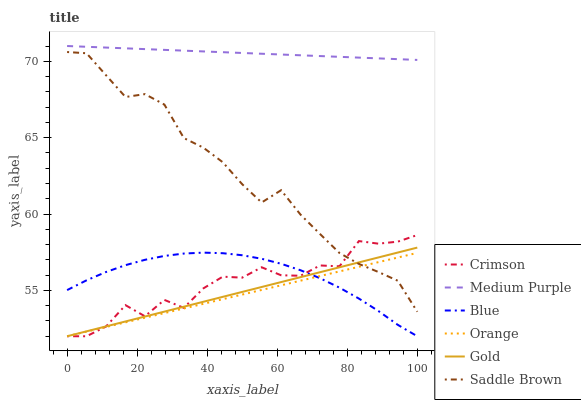Does Orange have the minimum area under the curve?
Answer yes or no. Yes. Does Medium Purple have the maximum area under the curve?
Answer yes or no. Yes. Does Gold have the minimum area under the curve?
Answer yes or no. No. Does Gold have the maximum area under the curve?
Answer yes or no. No. Is Medium Purple the smoothest?
Answer yes or no. Yes. Is Crimson the roughest?
Answer yes or no. Yes. Is Gold the smoothest?
Answer yes or no. No. Is Gold the roughest?
Answer yes or no. No. Does Medium Purple have the lowest value?
Answer yes or no. No. Does Medium Purple have the highest value?
Answer yes or no. Yes. Does Gold have the highest value?
Answer yes or no. No. Is Gold less than Medium Purple?
Answer yes or no. Yes. Is Saddle Brown greater than Blue?
Answer yes or no. Yes. Does Gold intersect Saddle Brown?
Answer yes or no. Yes. Is Gold less than Saddle Brown?
Answer yes or no. No. Is Gold greater than Saddle Brown?
Answer yes or no. No. Does Gold intersect Medium Purple?
Answer yes or no. No. 